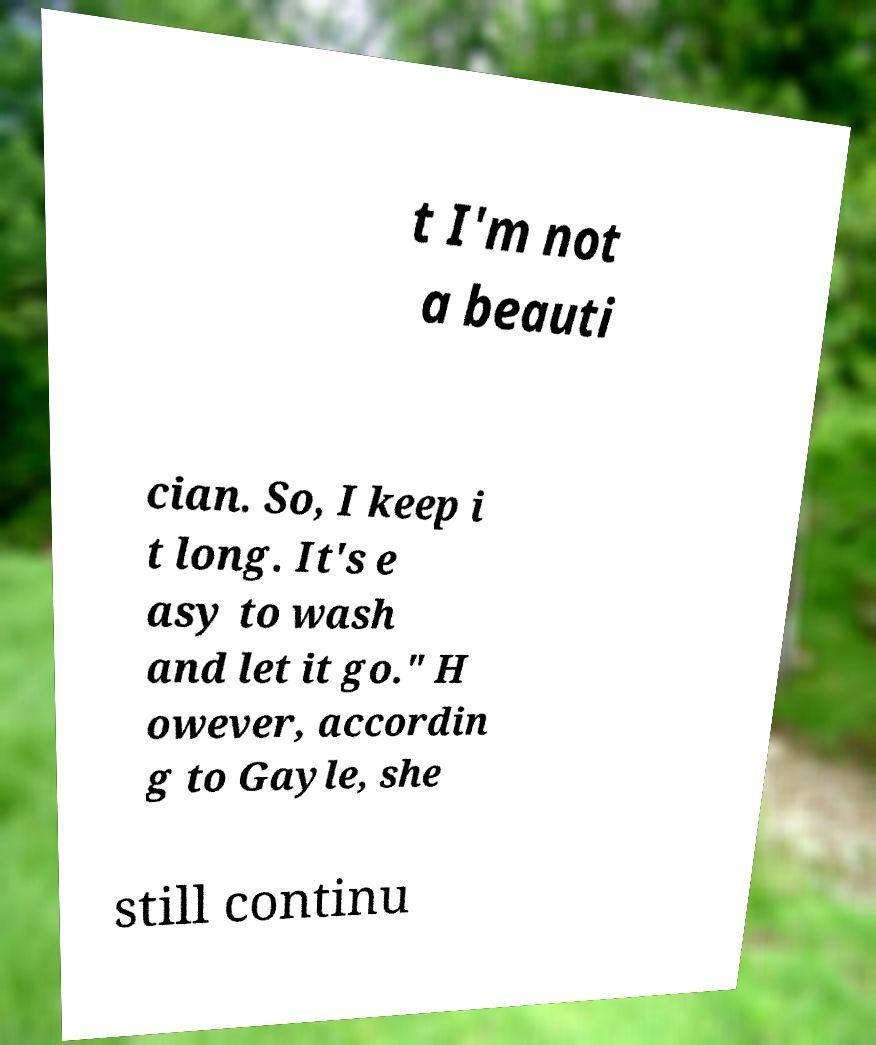Could you assist in decoding the text presented in this image and type it out clearly? t I'm not a beauti cian. So, I keep i t long. It's e asy to wash and let it go." H owever, accordin g to Gayle, she still continu 